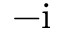Convert formula to latex. <formula><loc_0><loc_0><loc_500><loc_500>- i</formula> 